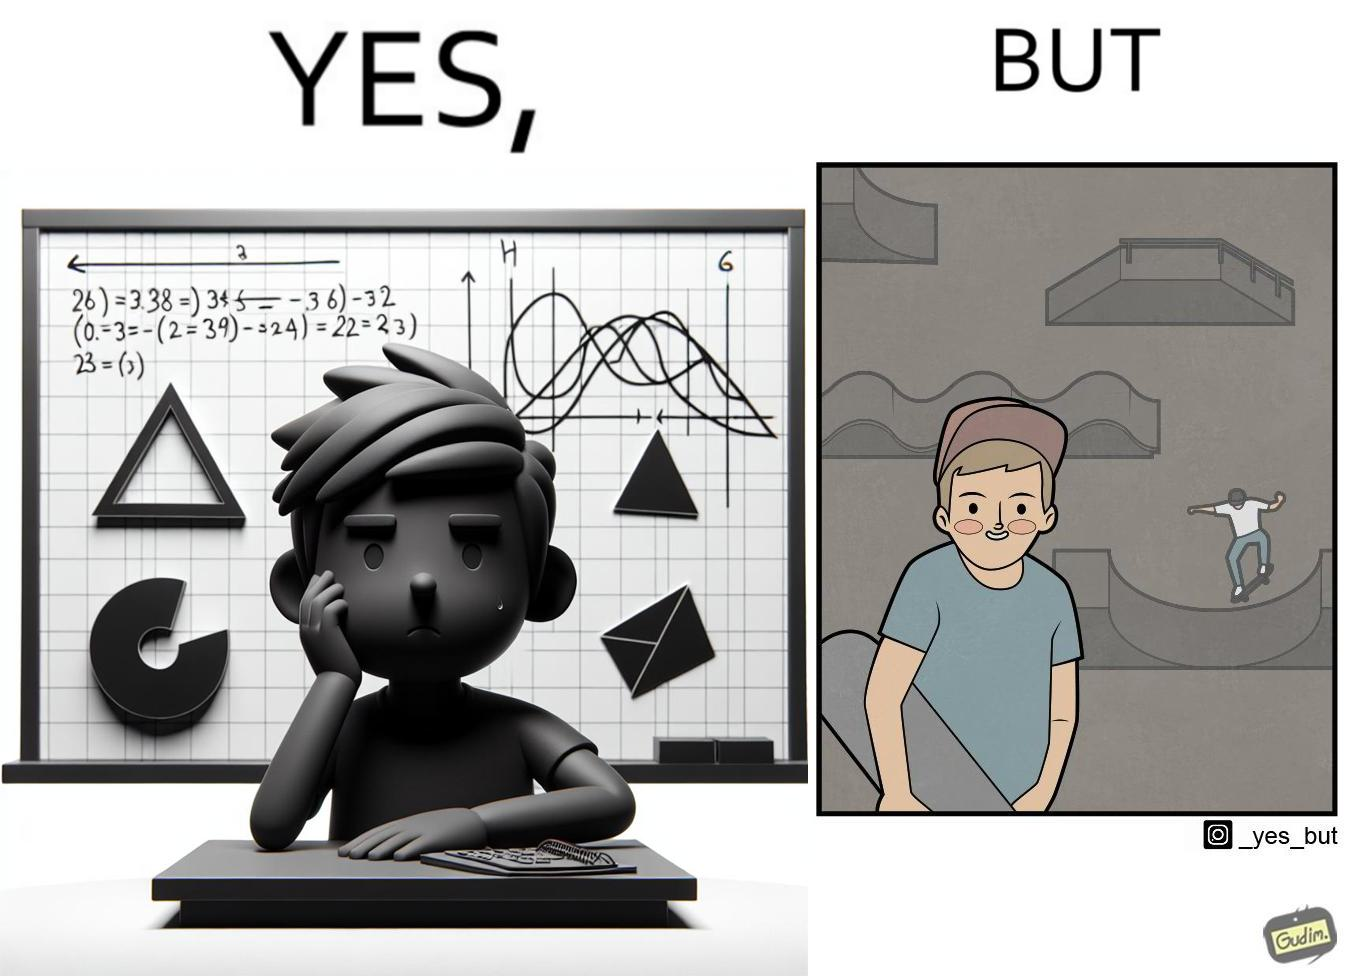Is there satirical content in this image? Yes, this image is satirical. 